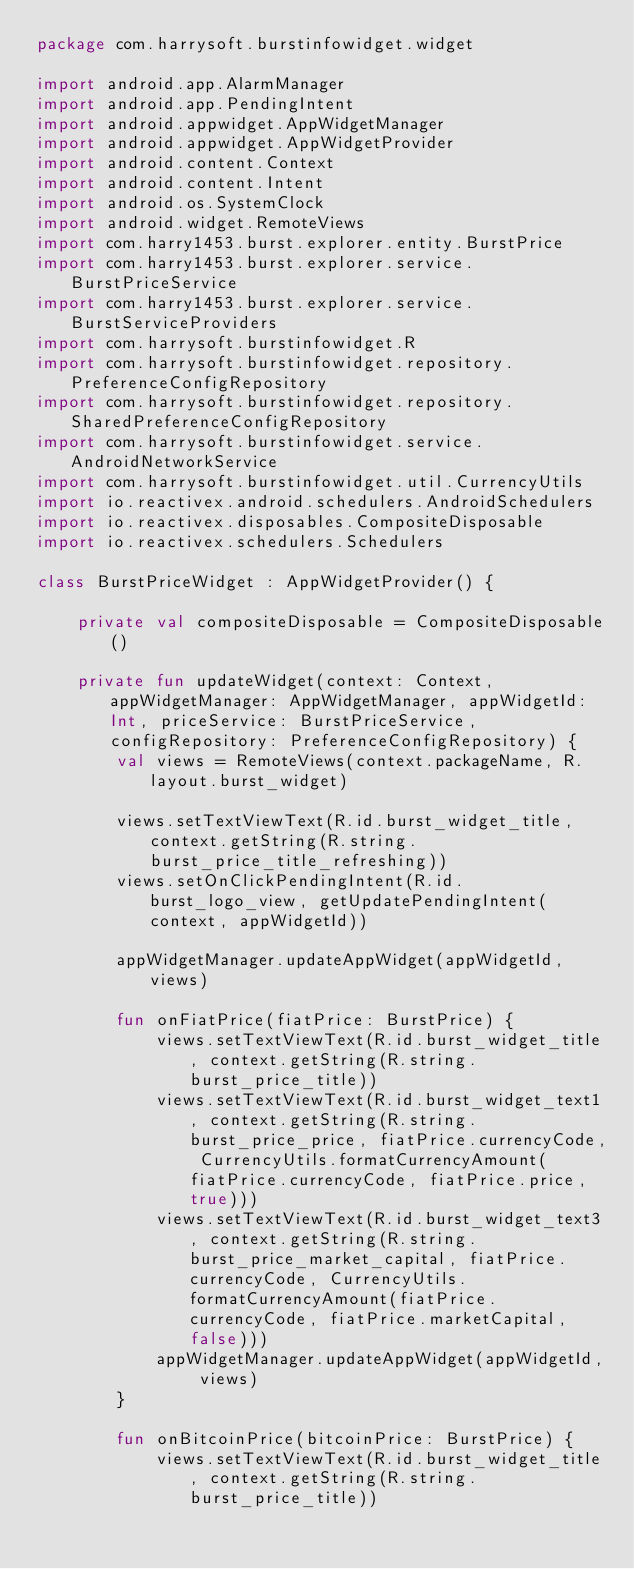Convert code to text. <code><loc_0><loc_0><loc_500><loc_500><_Kotlin_>package com.harrysoft.burstinfowidget.widget

import android.app.AlarmManager
import android.app.PendingIntent
import android.appwidget.AppWidgetManager
import android.appwidget.AppWidgetProvider
import android.content.Context
import android.content.Intent
import android.os.SystemClock
import android.widget.RemoteViews
import com.harry1453.burst.explorer.entity.BurstPrice
import com.harry1453.burst.explorer.service.BurstPriceService
import com.harry1453.burst.explorer.service.BurstServiceProviders
import com.harrysoft.burstinfowidget.R
import com.harrysoft.burstinfowidget.repository.PreferenceConfigRepository
import com.harrysoft.burstinfowidget.repository.SharedPreferenceConfigRepository
import com.harrysoft.burstinfowidget.service.AndroidNetworkService
import com.harrysoft.burstinfowidget.util.CurrencyUtils
import io.reactivex.android.schedulers.AndroidSchedulers
import io.reactivex.disposables.CompositeDisposable
import io.reactivex.schedulers.Schedulers

class BurstPriceWidget : AppWidgetProvider() {

    private val compositeDisposable = CompositeDisposable()

    private fun updateWidget(context: Context, appWidgetManager: AppWidgetManager, appWidgetId: Int, priceService: BurstPriceService, configRepository: PreferenceConfigRepository) {
        val views = RemoteViews(context.packageName, R.layout.burst_widget)

        views.setTextViewText(R.id.burst_widget_title, context.getString(R.string.burst_price_title_refreshing))
        views.setOnClickPendingIntent(R.id.burst_logo_view, getUpdatePendingIntent(context, appWidgetId))

        appWidgetManager.updateAppWidget(appWidgetId, views)

        fun onFiatPrice(fiatPrice: BurstPrice) {
            views.setTextViewText(R.id.burst_widget_title, context.getString(R.string.burst_price_title))
            views.setTextViewText(R.id.burst_widget_text1, context.getString(R.string.burst_price_price, fiatPrice.currencyCode, CurrencyUtils.formatCurrencyAmount(fiatPrice.currencyCode, fiatPrice.price, true)))
            views.setTextViewText(R.id.burst_widget_text3, context.getString(R.string.burst_price_market_capital, fiatPrice.currencyCode, CurrencyUtils.formatCurrencyAmount(fiatPrice.currencyCode, fiatPrice.marketCapital, false)))
            appWidgetManager.updateAppWidget(appWidgetId, views)
        }

        fun onBitcoinPrice(bitcoinPrice: BurstPrice) {
            views.setTextViewText(R.id.burst_widget_title, context.getString(R.string.burst_price_title))</code> 